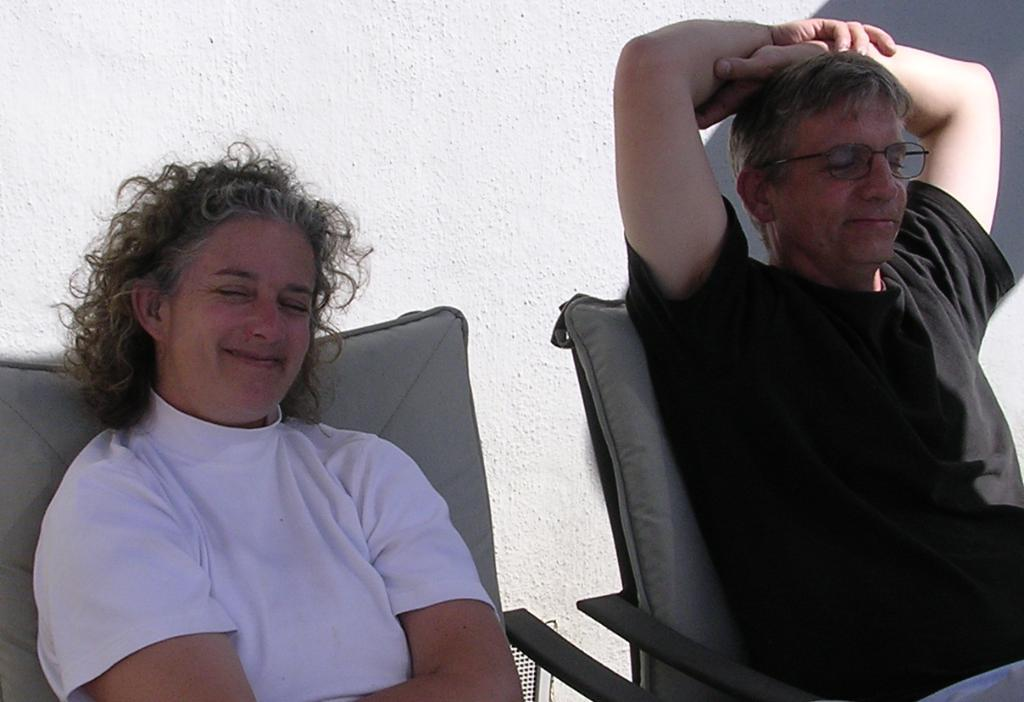How many people are in the image? There are two persons in the image. What are the persons doing in the image? The persons are sitting on chairs and smiling. What can be seen in the background of the image? There is a wall in the background of the image. What type of oil can be seen dripping from the father's throat in the image? There is no father or oil present in the image; it features two persons sitting on chairs and smiling. 